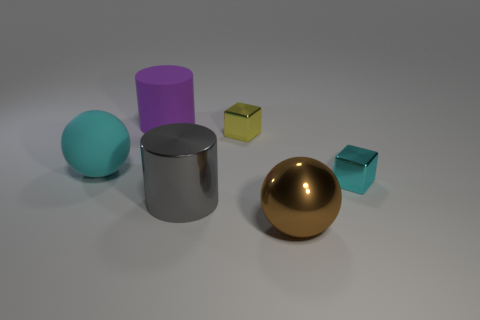What size is the yellow metallic thing that is right of the large cylinder to the left of the gray cylinder?
Provide a succinct answer. Small. Are there fewer large cyan metal cylinders than objects?
Provide a succinct answer. Yes. The object that is behind the cyan matte thing and to the left of the tiny yellow block is made of what material?
Your answer should be compact. Rubber. There is a block that is on the left side of the tiny cyan shiny object; is there a metal sphere in front of it?
Make the answer very short. Yes. What number of objects are big cyan metallic things or brown metal spheres?
Make the answer very short. 1. What is the shape of the metallic object that is both to the left of the large brown metallic thing and behind the big gray cylinder?
Offer a terse response. Cube. Do the large thing that is to the left of the big rubber cylinder and the gray cylinder have the same material?
Give a very brief answer. No. What number of things are either big metal objects or cyan objects that are left of the tiny yellow shiny object?
Give a very brief answer. 3. The ball that is made of the same material as the small cyan object is what color?
Your response must be concise. Brown. What number of big yellow balls have the same material as the yellow thing?
Provide a succinct answer. 0. 